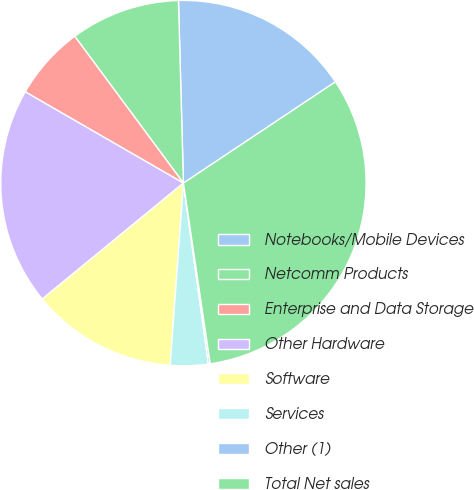Convert chart. <chart><loc_0><loc_0><loc_500><loc_500><pie_chart><fcel>Notebooks/Mobile Devices<fcel>Netcomm Products<fcel>Enterprise and Data Storage<fcel>Other Hardware<fcel>Software<fcel>Services<fcel>Other (1)<fcel>Total Net sales<nl><fcel>16.08%<fcel>9.71%<fcel>6.53%<fcel>19.27%<fcel>12.9%<fcel>3.34%<fcel>0.16%<fcel>32.01%<nl></chart> 